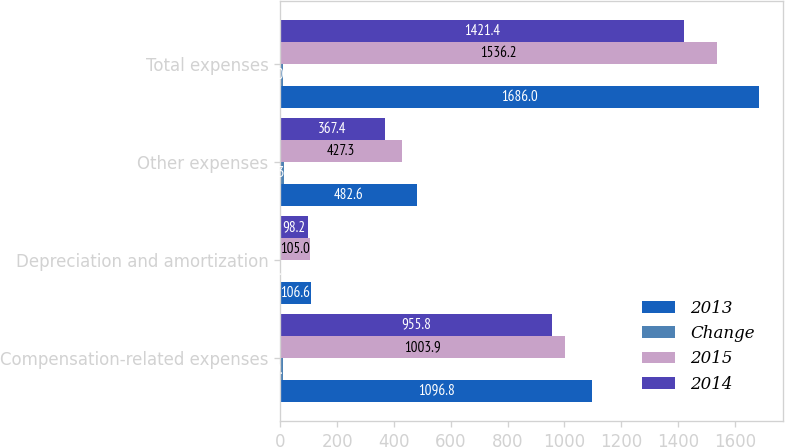<chart> <loc_0><loc_0><loc_500><loc_500><stacked_bar_chart><ecel><fcel>Compensation-related expenses<fcel>Depreciation and amortization<fcel>Other expenses<fcel>Total expenses<nl><fcel>2013<fcel>1096.8<fcel>106.6<fcel>482.6<fcel>1686<nl><fcel>Change<fcel>9<fcel>2<fcel>13<fcel>10<nl><fcel>2015<fcel>1003.9<fcel>105<fcel>427.3<fcel>1536.2<nl><fcel>2014<fcel>955.8<fcel>98.2<fcel>367.4<fcel>1421.4<nl></chart> 